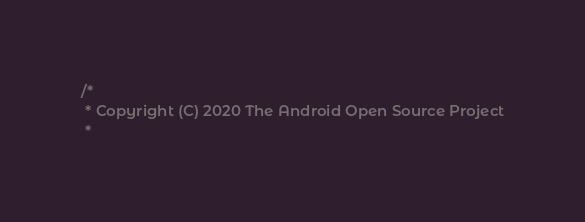Convert code to text. <code><loc_0><loc_0><loc_500><loc_500><_C_>/*
 * Copyright (C) 2020 The Android Open Source Project
 *</code> 